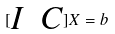<formula> <loc_0><loc_0><loc_500><loc_500>[ \begin{matrix} I & C \end{matrix} ] X = b</formula> 